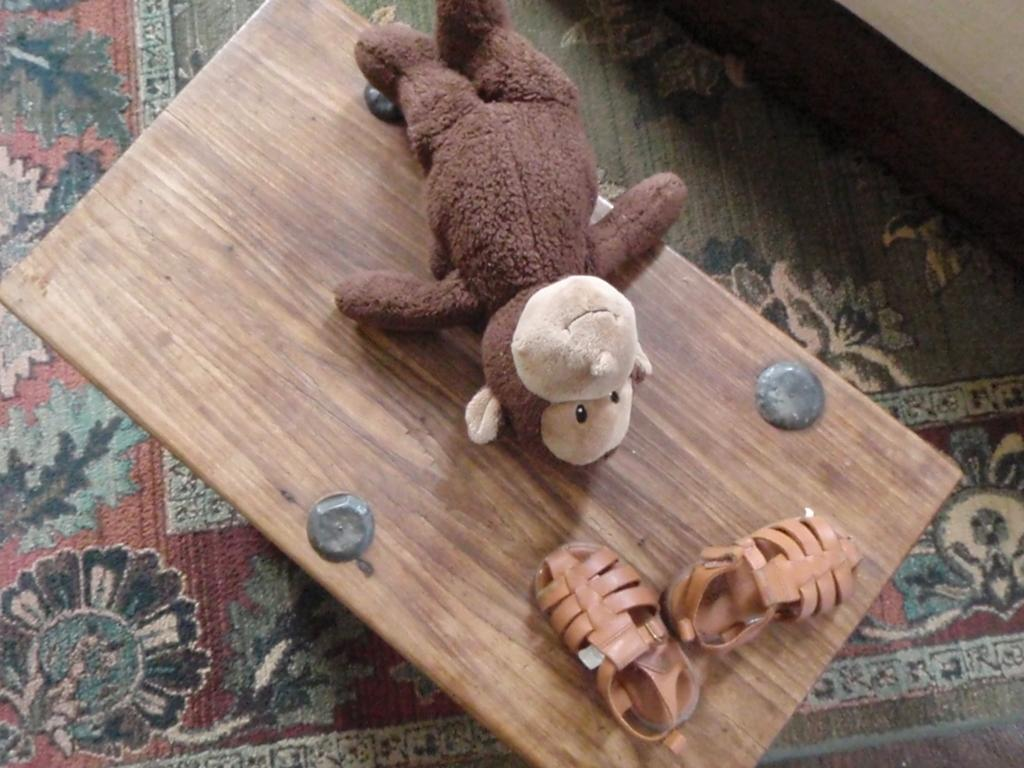What object in the image is typically used for play? There is a toy in the image. What item is placed on the table in the image? There is footwear on the table in the image. What type of floor covering is visible at the bottom of the image? There is a floral mat at the bottom of the image. How many kisses can be seen on the toy in the image? There are no kisses present on the toy in the image. What type of finger is shown interacting with the footwear on the table? There are no fingers visible in the image, and therefore no such interaction can be observed. 